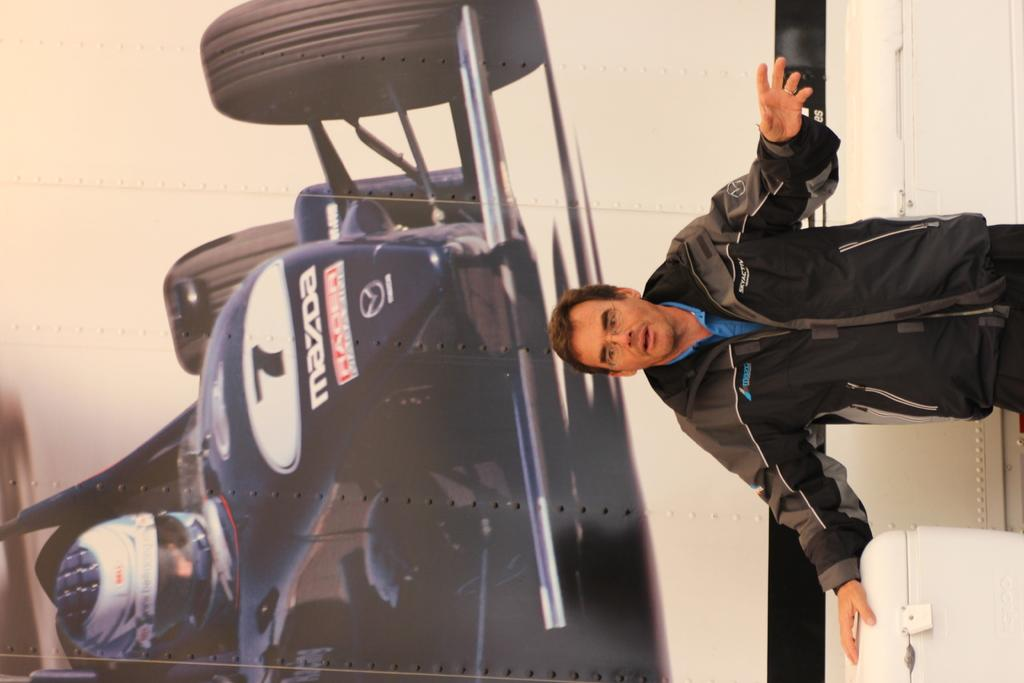Provide a one-sentence caption for the provided image. A man standing in front of a picture of a Mazda race car. 